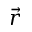<formula> <loc_0><loc_0><loc_500><loc_500>\vec { r }</formula> 